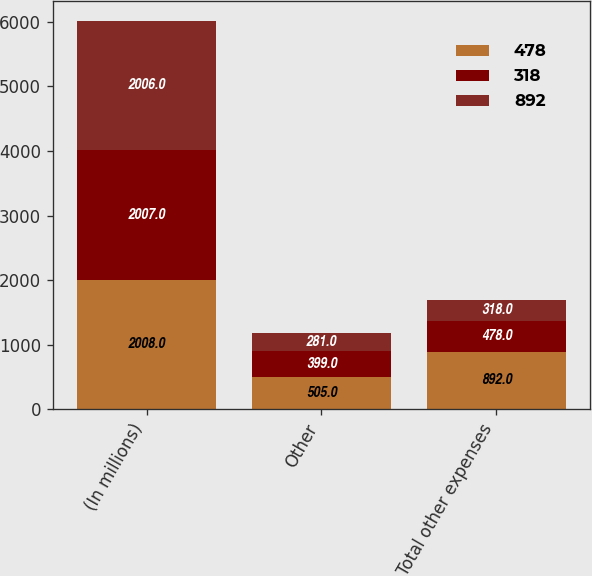Convert chart. <chart><loc_0><loc_0><loc_500><loc_500><stacked_bar_chart><ecel><fcel>(In millions)<fcel>Other<fcel>Total other expenses<nl><fcel>478<fcel>2008<fcel>505<fcel>892<nl><fcel>318<fcel>2007<fcel>399<fcel>478<nl><fcel>892<fcel>2006<fcel>281<fcel>318<nl></chart> 